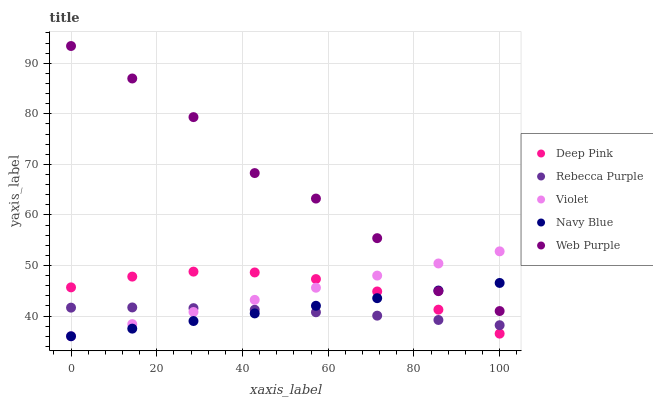Does Rebecca Purple have the minimum area under the curve?
Answer yes or no. Yes. Does Web Purple have the maximum area under the curve?
Answer yes or no. Yes. Does Deep Pink have the minimum area under the curve?
Answer yes or no. No. Does Deep Pink have the maximum area under the curve?
Answer yes or no. No. Is Violet the smoothest?
Answer yes or no. Yes. Is Web Purple the roughest?
Answer yes or no. Yes. Is Deep Pink the smoothest?
Answer yes or no. No. Is Deep Pink the roughest?
Answer yes or no. No. Does Navy Blue have the lowest value?
Answer yes or no. Yes. Does Deep Pink have the lowest value?
Answer yes or no. No. Does Web Purple have the highest value?
Answer yes or no. Yes. Does Deep Pink have the highest value?
Answer yes or no. No. Is Rebecca Purple less than Web Purple?
Answer yes or no. Yes. Is Web Purple greater than Rebecca Purple?
Answer yes or no. Yes. Does Rebecca Purple intersect Navy Blue?
Answer yes or no. Yes. Is Rebecca Purple less than Navy Blue?
Answer yes or no. No. Is Rebecca Purple greater than Navy Blue?
Answer yes or no. No. Does Rebecca Purple intersect Web Purple?
Answer yes or no. No. 